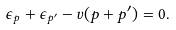Convert formula to latex. <formula><loc_0><loc_0><loc_500><loc_500>\epsilon _ { p } + \epsilon _ { p ^ { \prime } } - v ( p + p ^ { \prime } ) = 0 .</formula> 